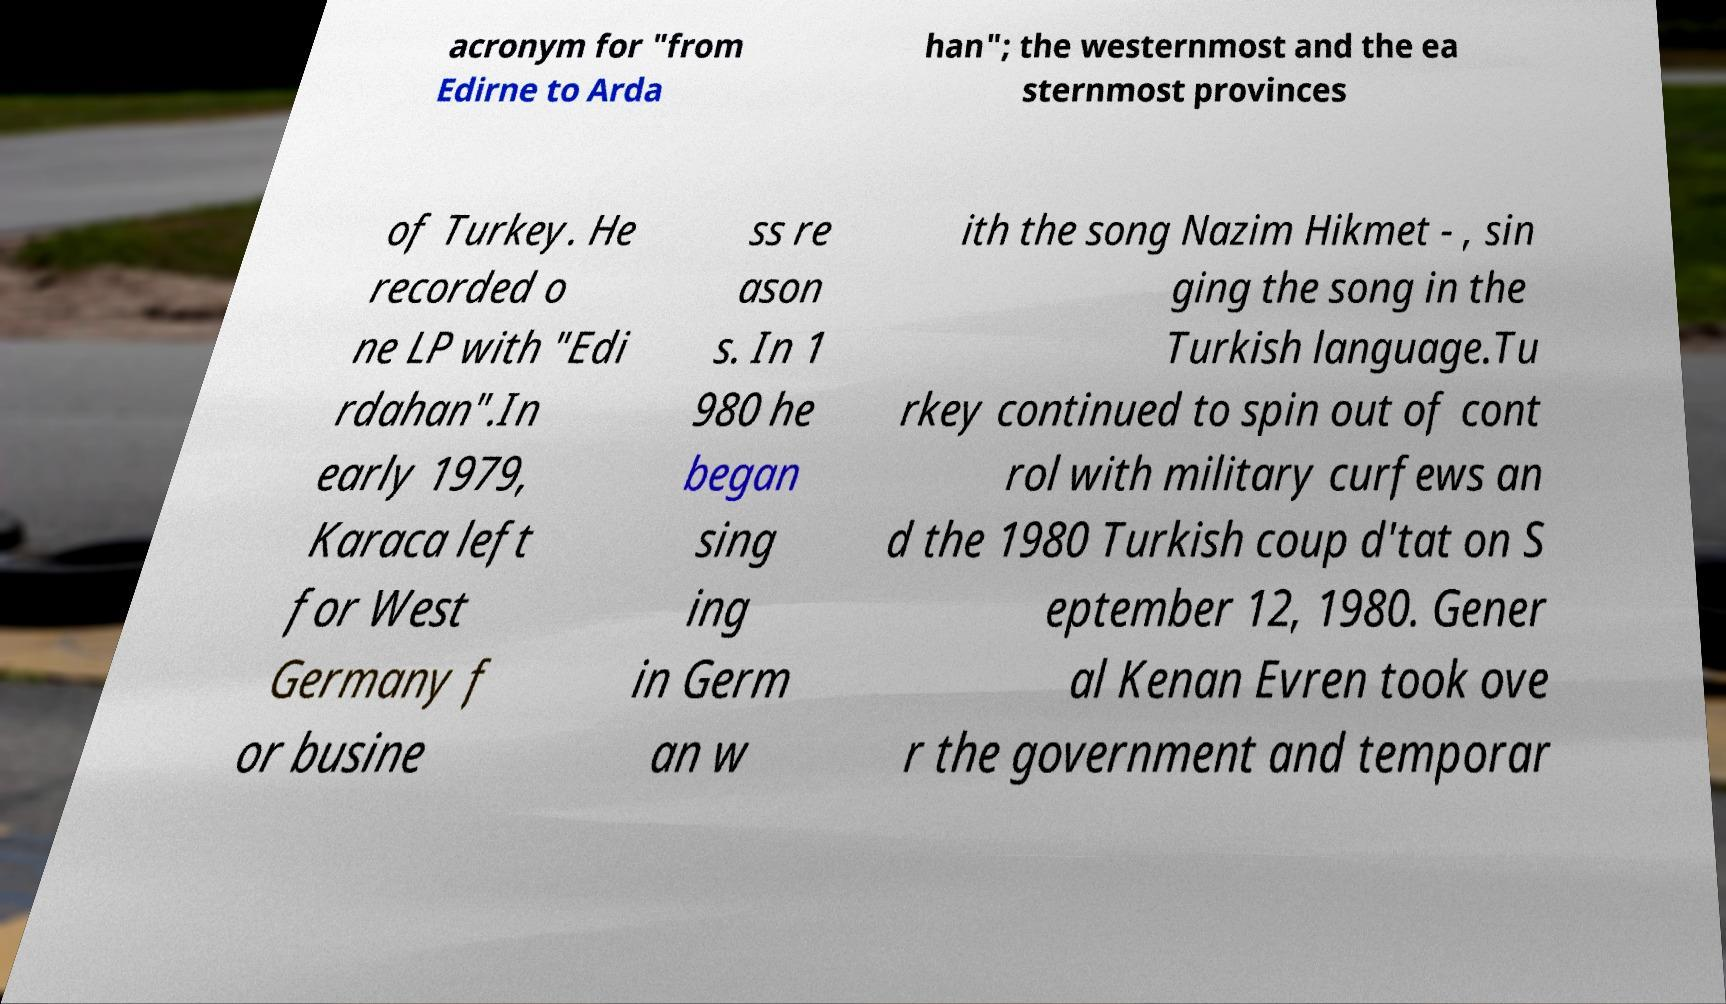What messages or text are displayed in this image? I need them in a readable, typed format. acronym for "from Edirne to Arda han"; the westernmost and the ea sternmost provinces of Turkey. He recorded o ne LP with "Edi rdahan".In early 1979, Karaca left for West Germany f or busine ss re ason s. In 1 980 he began sing ing in Germ an w ith the song Nazim Hikmet - , sin ging the song in the Turkish language.Tu rkey continued to spin out of cont rol with military curfews an d the 1980 Turkish coup d'tat on S eptember 12, 1980. Gener al Kenan Evren took ove r the government and temporar 